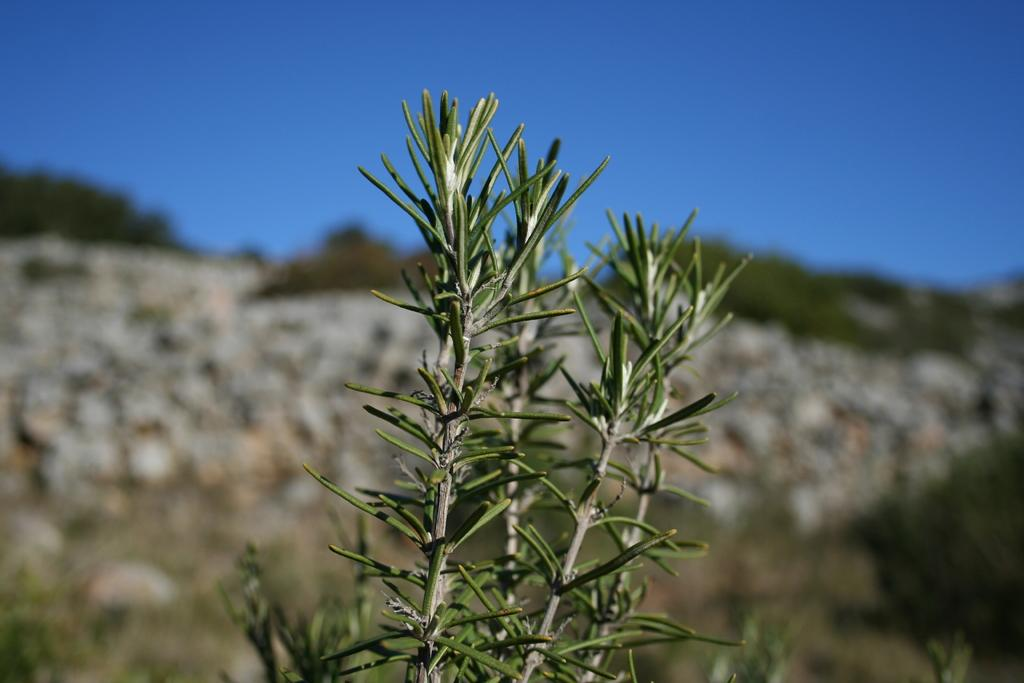What type of plants can be seen in the image? There are green plants in the image. What can be seen in the background of the image? The back side of the image has a long view. What color is the sky in the image? The sky in the image is blue. How many nails are used to hold the bucket in the image? There is no bucket or nails present in the image. 